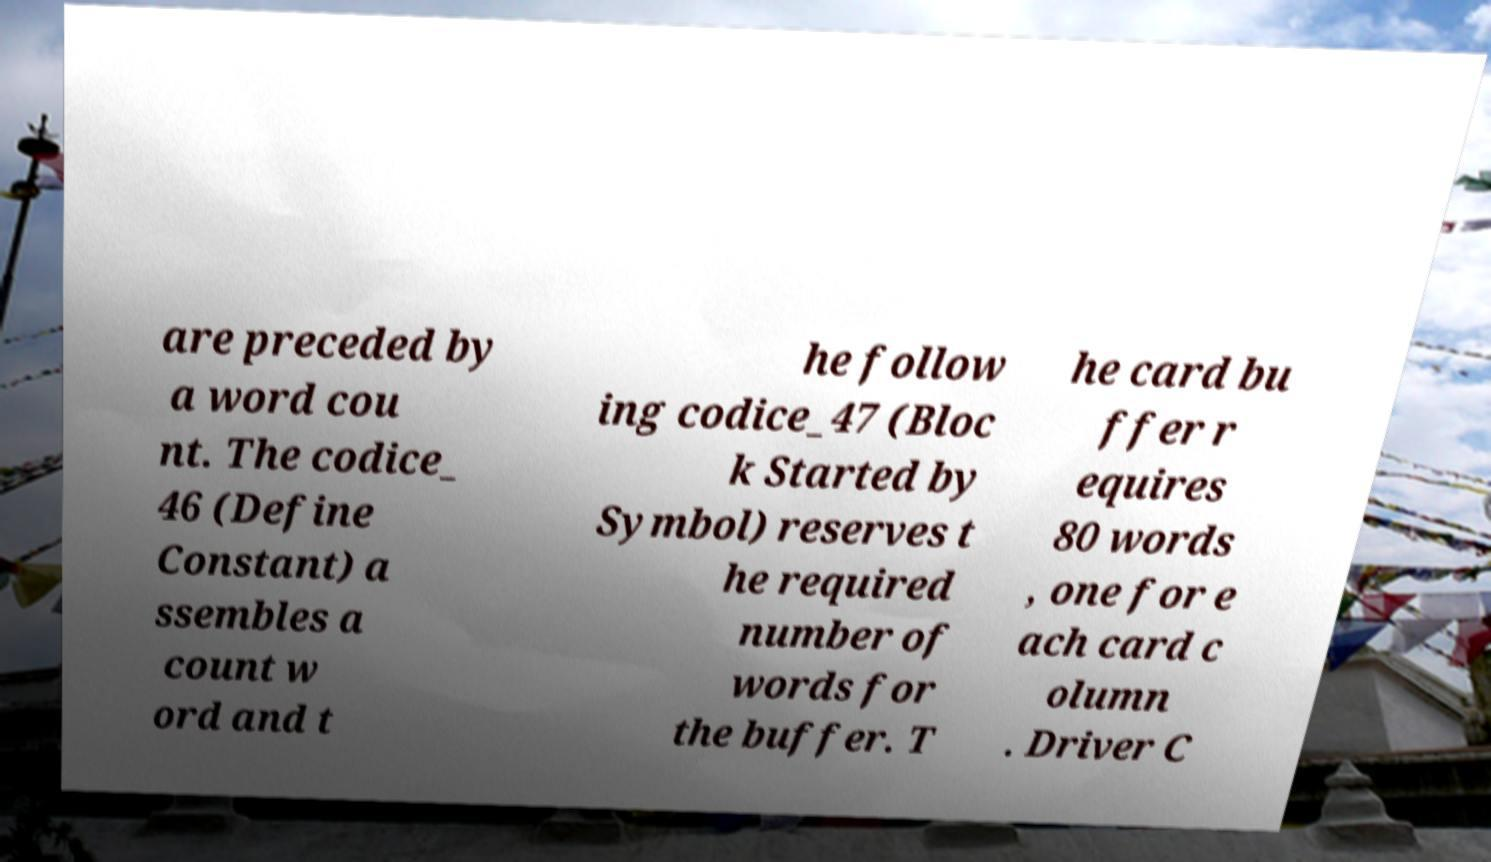Could you extract and type out the text from this image? are preceded by a word cou nt. The codice_ 46 (Define Constant) a ssembles a count w ord and t he follow ing codice_47 (Bloc k Started by Symbol) reserves t he required number of words for the buffer. T he card bu ffer r equires 80 words , one for e ach card c olumn . Driver C 